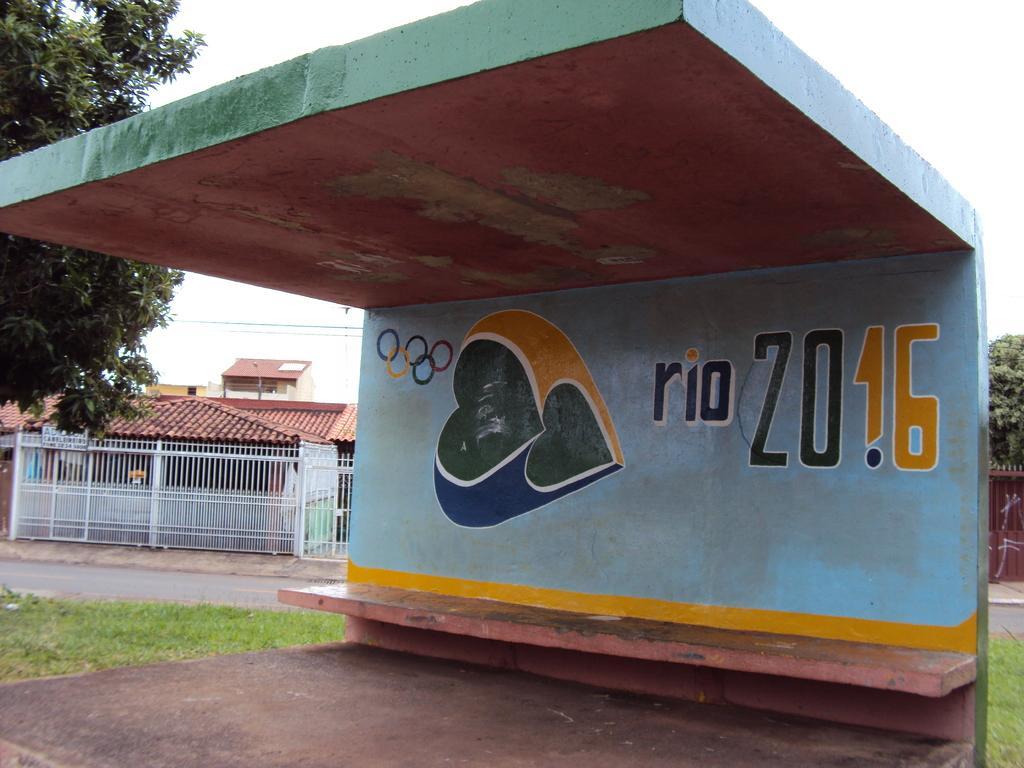Could you give a brief overview of what you see in this image? In the middle of the image there is a shed. Behind the shed there is grass and there is fencing and there are some buildings and trees. At the top of the image there is sky. 